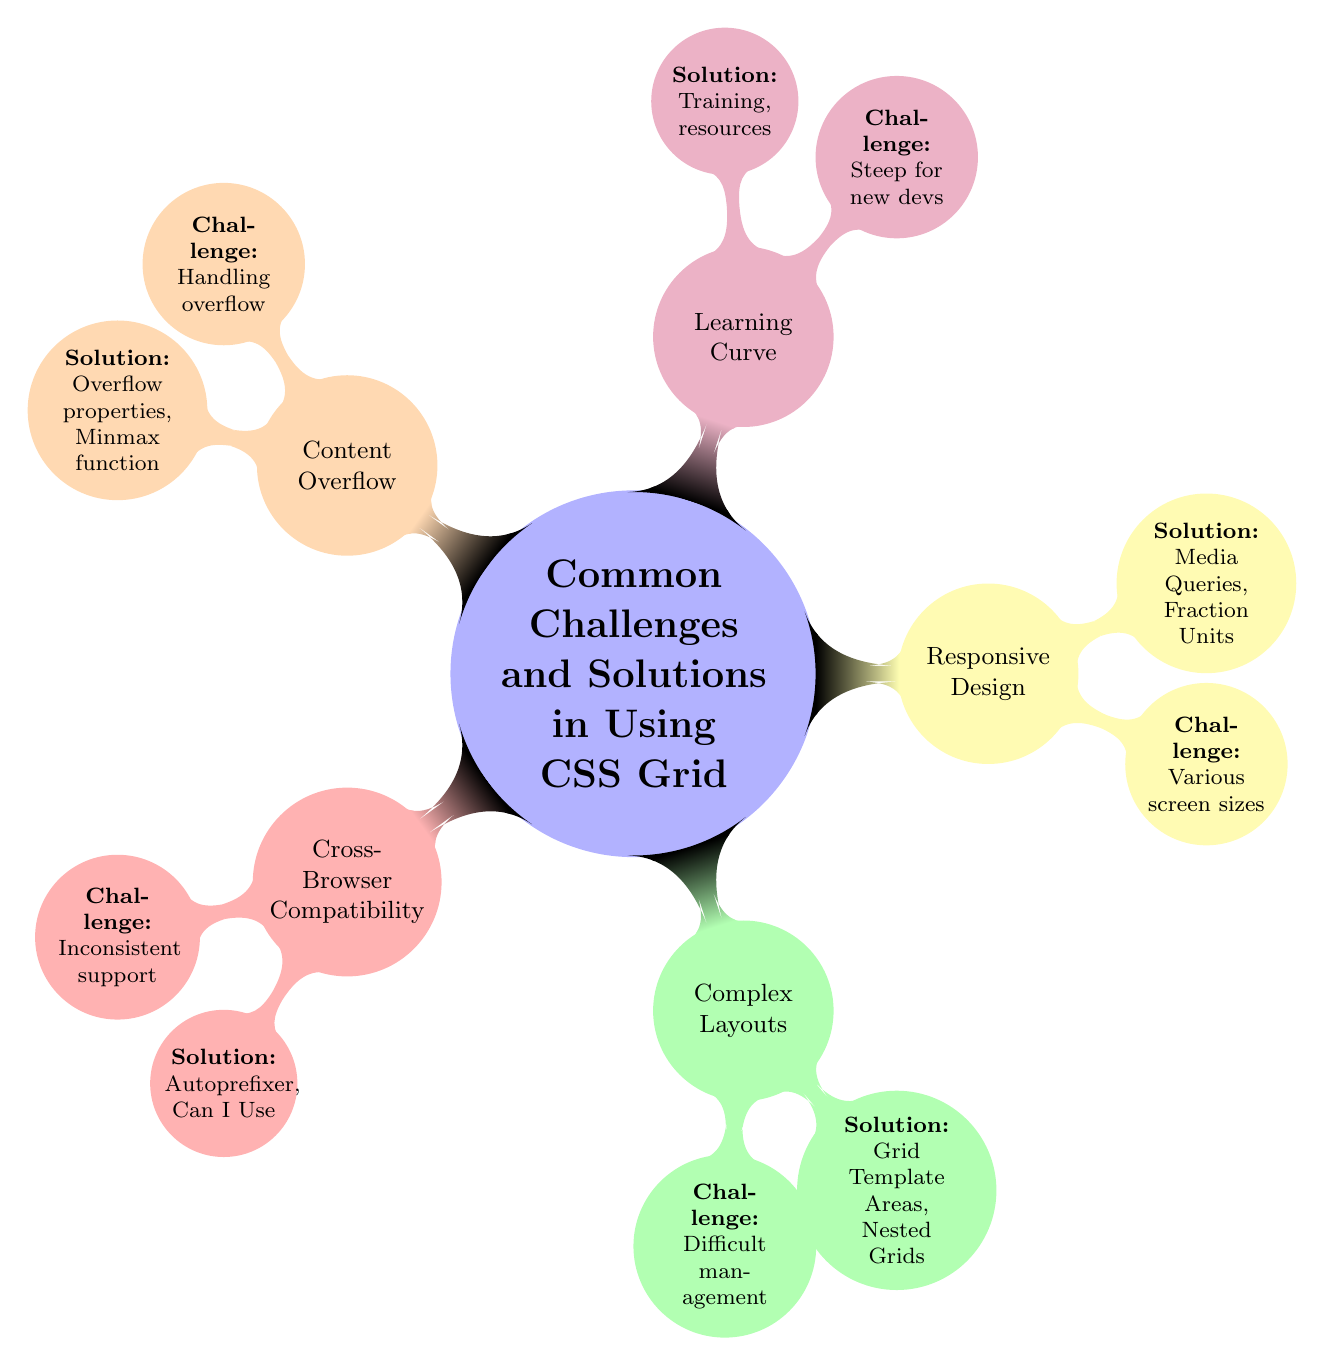What are the five main challenges listed in the diagram? The diagram lists five main challenges: Cross-Browser Compatibility, Complex Layouts, Responsive Design, Learning Curve, and Content Overflow. These are all outlined as individual nodes connected to the central theme of "Common Challenges and Solutions in Using CSS Grid."
Answer: Five Which node addresses the learning curve challenge? The node "Learning Curve" specifically addresses the challenge regarding how new developers find it steep, indicating it's a major topic in the diagram. It is connected to the central theme along with other challenges.
Answer: Learning Curve What solution is proposed for handling content overflow in grid items? The diagram suggests applying Overflow CSS properties and using the Minmax function as solutions to handle content overflow within grid items. This is a solution node connected to the Content Overflow challenge.
Answer: Overflow properties, Minmax function How many challenges are outlined in the diagram? The diagram outlines five challenges related to CSS Grid usage, each represented as a separate node coming off the central theme.
Answer: Five What is the proposed solution for managing complex layouts according to the diagram? The solution proposed for managing complex layouts is to employ Grid Template Areas and Nested Grids, which are listed under the Complex Layouts node. This indicates an approach to simplify managing layouts.
Answer: Grid Template Areas, Nested Grids Which challenge includes a solution involving media queries? The Responsive Design challenge includes a solution involving media queries, along with Fraction Units, indicating approaches to ensure layouts work on various screen sizes. This is explicitly mentioned in the Responsive Design node.
Answer: Responsive Design 